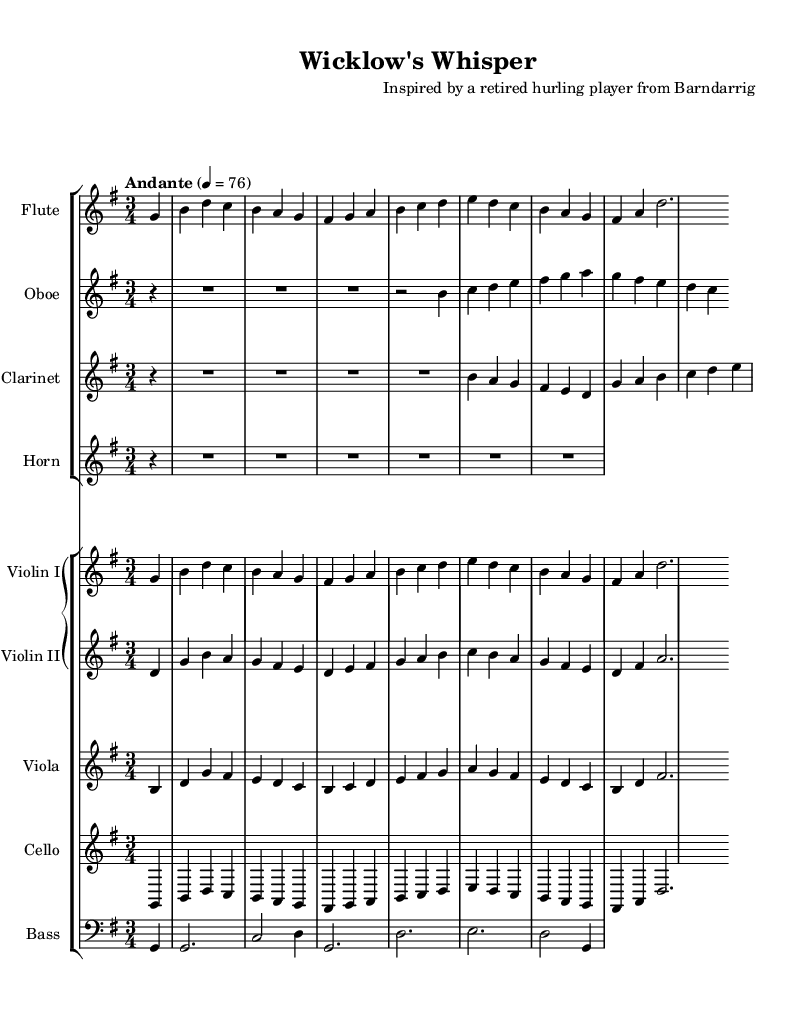What is the key signature of this music? The key signature is G major, indicated by the presence of one sharp (F#) at the beginning of the staff.
Answer: G major What is the time signature of this music? The time signature is 3/4, which is indicated at the beginning of the score after the key signature.
Answer: 3/4 What is the tempo marking for this composition? The tempo marking of "Andante" is shown above the staff, indicating a moderate pace. The metronome marking is 4 = 76.
Answer: Andante Which instrument has the melody in the opening? The flute plays the opening melody, as the notes begin with the flute staff and the melody starts immediately after the initial partial rest.
Answer: Flute How many measures are in the first section of the piece? The first section is composed of 4 measures, which can be counted by observing the grouping of notes and the bar lines.
Answer: 4 Which instrument plays the lowest pitch range in this orchestral score? The bass instrument plays the lowest pitch range, indicated by its staff placement and the notes written in the bass clef.
Answer: Bass Identify the dynamic markings used in this sheet music. The sheet music does not explicitly show dynamic markings, so it requires an understanding that dynamic expressions may be applied at the conductor's discretion.
Answer: None 